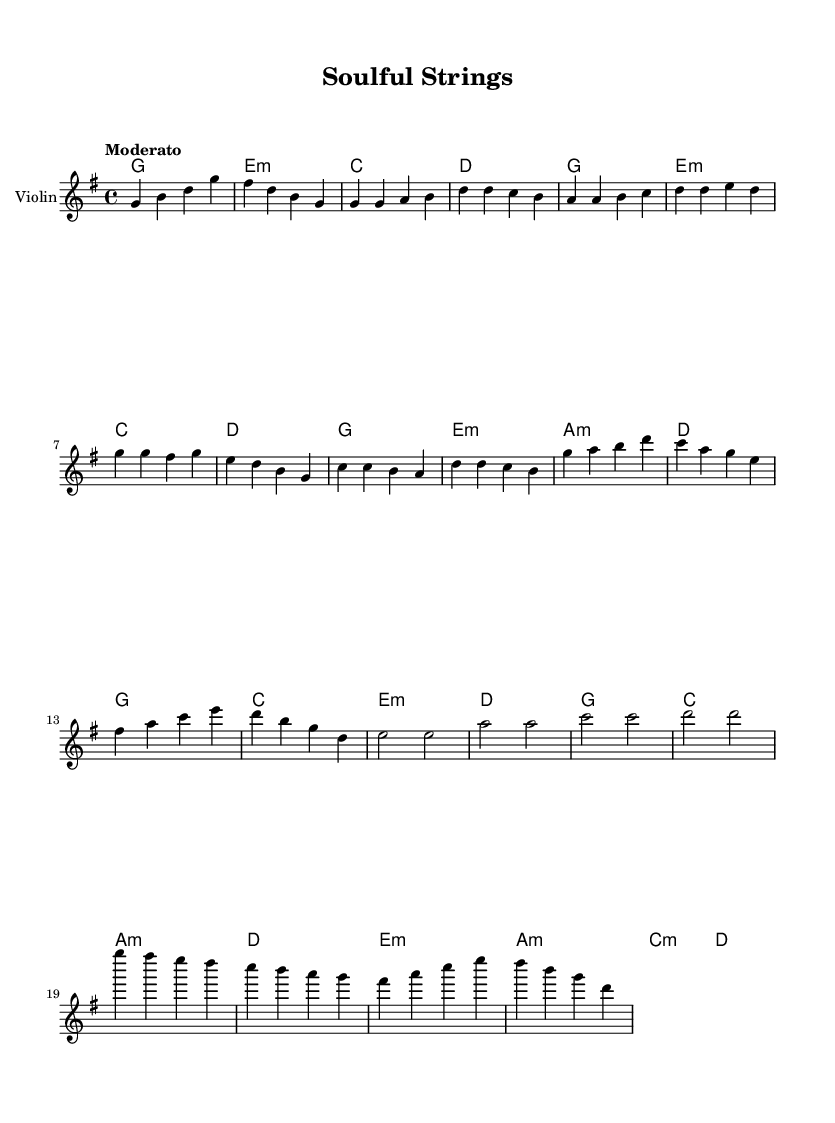What is the key signature of this music? The key signature can be found at the beginning of the staff. It shows one sharp (F#), indicating that the key signature is G major.
Answer: G major What is the time signature of this music? The time signature is indicated at the beginning of the staff (the "4/4" next to the key signature), which shows that there are four beats in each measure and a quarter note receives one beat.
Answer: 4/4 What is the tempo marking for this piece? The tempo marking is indicated above the staff at the beginning of the music; it shows "Moderato," which suggests a moderate speed for the performance of the piece.
Answer: Moderato How many violin solos are present in the piece? By examining the structure of the music, we find two sections labeled as "Violin Solo" (noted in the score) indicating that there are two distinct violin solos within the composition.
Answer: 2 What chord is played during the chorus? To find the chords played during the chorus, we can look at the chord names section and see the listed chords for that section. The chorus has the chords G, C, E minor, and D.
Answer: G, C, E minor, D What is the last note of the first violin solo? By looking at the notes in the "Violin Solo 1" section, the last note is a "D," which is at the end of the solo line.
Answer: D What is the primary mood suggested by this music style? The presence of gospel-influenced motifs, alongside strong, emotive violin lines, leads to the understanding that this piece captures the spirit of soulful expression, often associated with joy and spirituality.
Answer: Soulful expression 